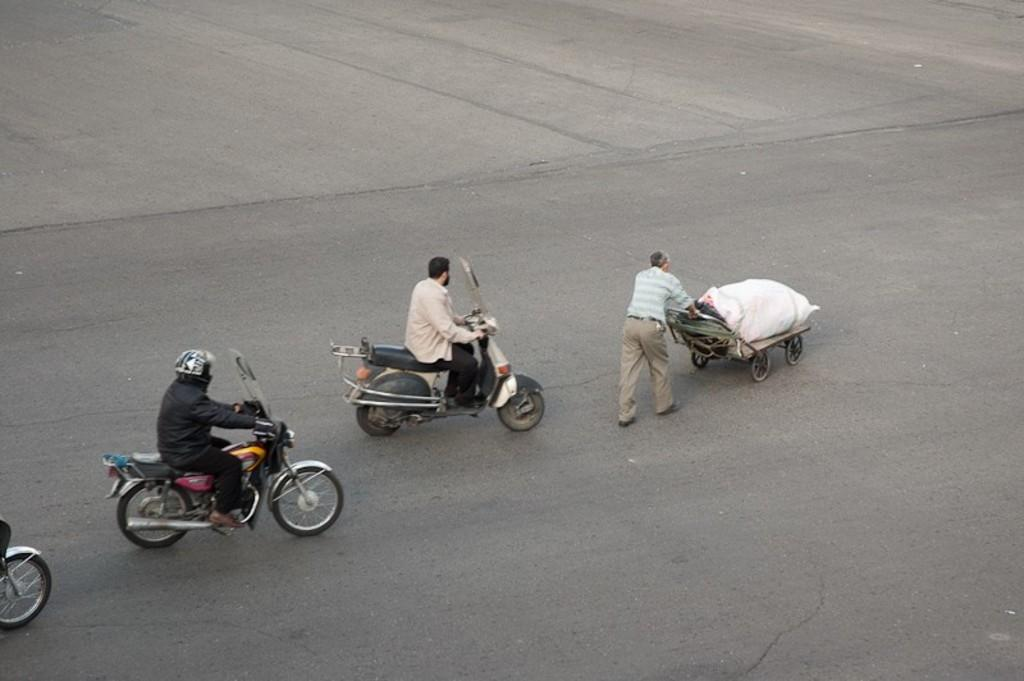What are the two men in the foreground of the image doing? The two men are on a cycle in the foreground of the image. How are the men moving in the image? The men are moving on the ground. Can you describe the other man in the foreground of the image? There is another man in the foreground of the image, and he is moving a cart on the ground. What type of team sport are the men playing in the image? There is no team sport being played in the image; the men are simply moving on a cycle and a cart. Can you describe the kiss between the two men on the cycle? There is no kiss between the two men on the cycle in the image. 